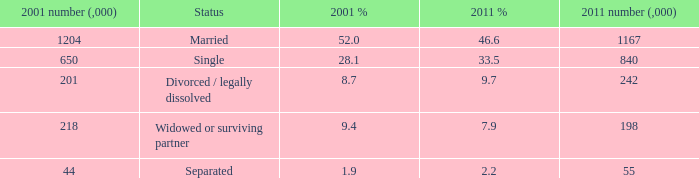How many 2011 % is 7.9? 1.0. 